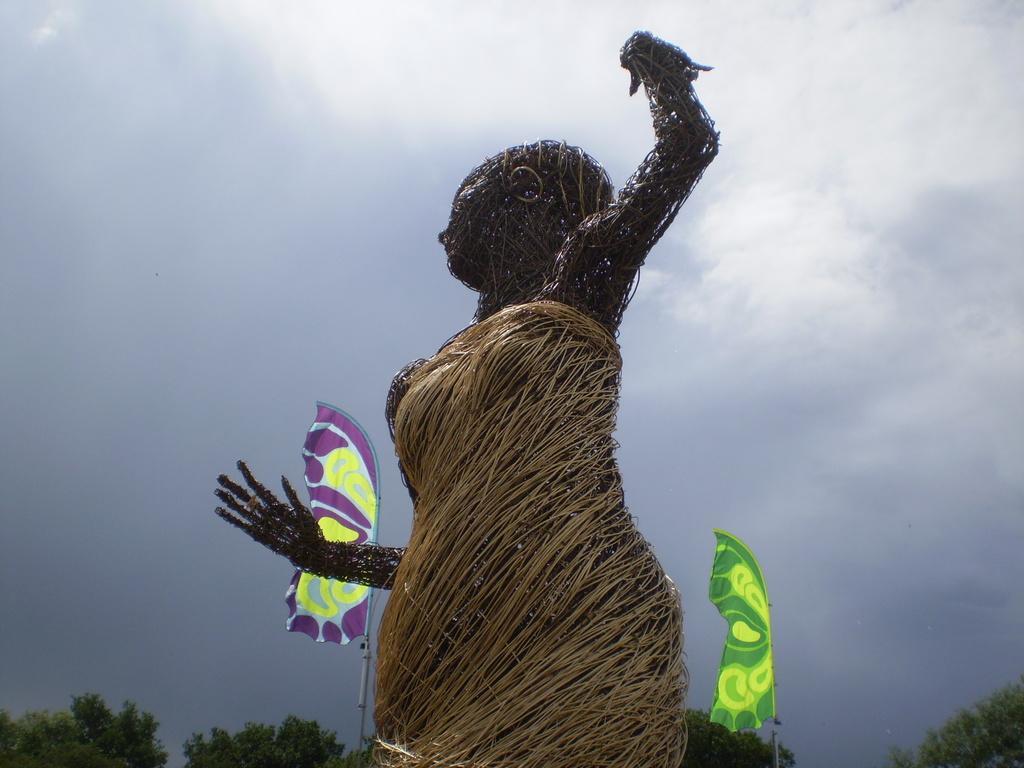Please provide a concise description of this image. Front we can see a statue. Background there are flags and trees. Sky is cloudy. 